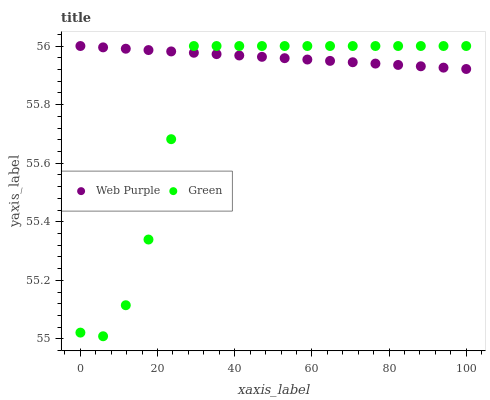Does Green have the minimum area under the curve?
Answer yes or no. Yes. Does Web Purple have the maximum area under the curve?
Answer yes or no. Yes. Does Green have the maximum area under the curve?
Answer yes or no. No. Is Web Purple the smoothest?
Answer yes or no. Yes. Is Green the roughest?
Answer yes or no. Yes. Is Green the smoothest?
Answer yes or no. No. Does Green have the lowest value?
Answer yes or no. Yes. Does Green have the highest value?
Answer yes or no. Yes. Does Web Purple intersect Green?
Answer yes or no. Yes. Is Web Purple less than Green?
Answer yes or no. No. Is Web Purple greater than Green?
Answer yes or no. No. 